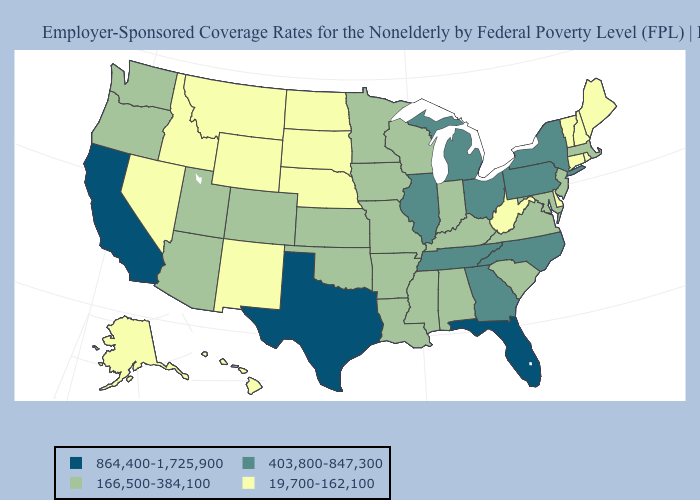Name the states that have a value in the range 166,500-384,100?
Give a very brief answer. Alabama, Arizona, Arkansas, Colorado, Indiana, Iowa, Kansas, Kentucky, Louisiana, Maryland, Massachusetts, Minnesota, Mississippi, Missouri, New Jersey, Oklahoma, Oregon, South Carolina, Utah, Virginia, Washington, Wisconsin. Does Iowa have the highest value in the MidWest?
Keep it brief. No. Name the states that have a value in the range 403,800-847,300?
Answer briefly. Georgia, Illinois, Michigan, New York, North Carolina, Ohio, Pennsylvania, Tennessee. What is the value of South Carolina?
Short answer required. 166,500-384,100. What is the value of Nebraska?
Be succinct. 19,700-162,100. Is the legend a continuous bar?
Answer briefly. No. What is the highest value in the USA?
Quick response, please. 864,400-1,725,900. What is the value of Kentucky?
Quick response, please. 166,500-384,100. Does New York have the lowest value in the Northeast?
Quick response, please. No. Which states have the highest value in the USA?
Short answer required. California, Florida, Texas. Which states have the highest value in the USA?
Give a very brief answer. California, Florida, Texas. Does the map have missing data?
Be succinct. No. Does Colorado have the lowest value in the West?
Concise answer only. No. Is the legend a continuous bar?
Short answer required. No. What is the value of Florida?
Give a very brief answer. 864,400-1,725,900. 